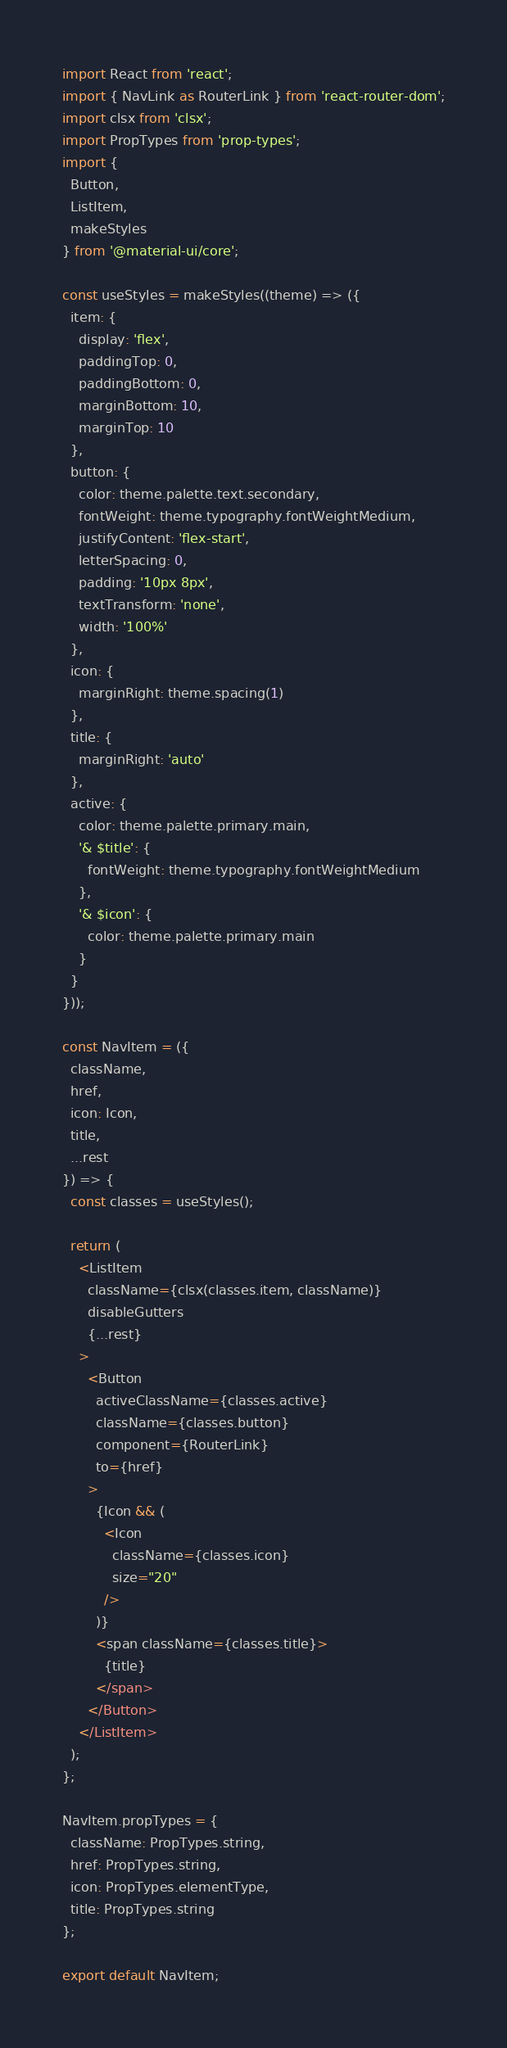<code> <loc_0><loc_0><loc_500><loc_500><_JavaScript_>import React from 'react';
import { NavLink as RouterLink } from 'react-router-dom';
import clsx from 'clsx';
import PropTypes from 'prop-types';
import {
  Button,
  ListItem,
  makeStyles
} from '@material-ui/core';

const useStyles = makeStyles((theme) => ({
  item: {
    display: 'flex',
    paddingTop: 0,
    paddingBottom: 0,
    marginBottom: 10,
    marginTop: 10
  },
  button: {
    color: theme.palette.text.secondary,
    fontWeight: theme.typography.fontWeightMedium,
    justifyContent: 'flex-start',
    letterSpacing: 0,
    padding: '10px 8px',
    textTransform: 'none',
    width: '100%'
  },
  icon: {
    marginRight: theme.spacing(1)
  },
  title: {
    marginRight: 'auto'
  },
  active: {
    color: theme.palette.primary.main,
    '& $title': {
      fontWeight: theme.typography.fontWeightMedium
    },
    '& $icon': {
      color: theme.palette.primary.main
    }
  }
}));

const NavItem = ({
  className,
  href,
  icon: Icon,
  title,
  ...rest
}) => {
  const classes = useStyles();

  return (
    <ListItem
      className={clsx(classes.item, className)}
      disableGutters
      {...rest}
    >
      <Button
        activeClassName={classes.active}
        className={classes.button}
        component={RouterLink}
        to={href}
      >
        {Icon && (
          <Icon
            className={classes.icon}
            size="20"
          />
        )}
        <span className={classes.title}>
          {title}
        </span>
      </Button>
    </ListItem>
  );
};

NavItem.propTypes = {
  className: PropTypes.string,
  href: PropTypes.string,
  icon: PropTypes.elementType,
  title: PropTypes.string
};

export default NavItem;
</code> 